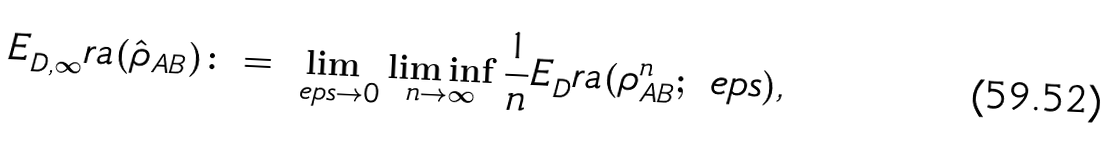Convert formula to latex. <formula><loc_0><loc_0><loc_500><loc_500>E _ { D , \infty } ^ { \ } r a ( \hat { \rho } _ { A B } ) \colon = \lim _ { \ e p s \to 0 } \liminf _ { n \to \infty } \frac { 1 } { n } E _ { D } ^ { \ } r a ( \rho _ { A B } ^ { n } ; \ e p s ) ,</formula> 